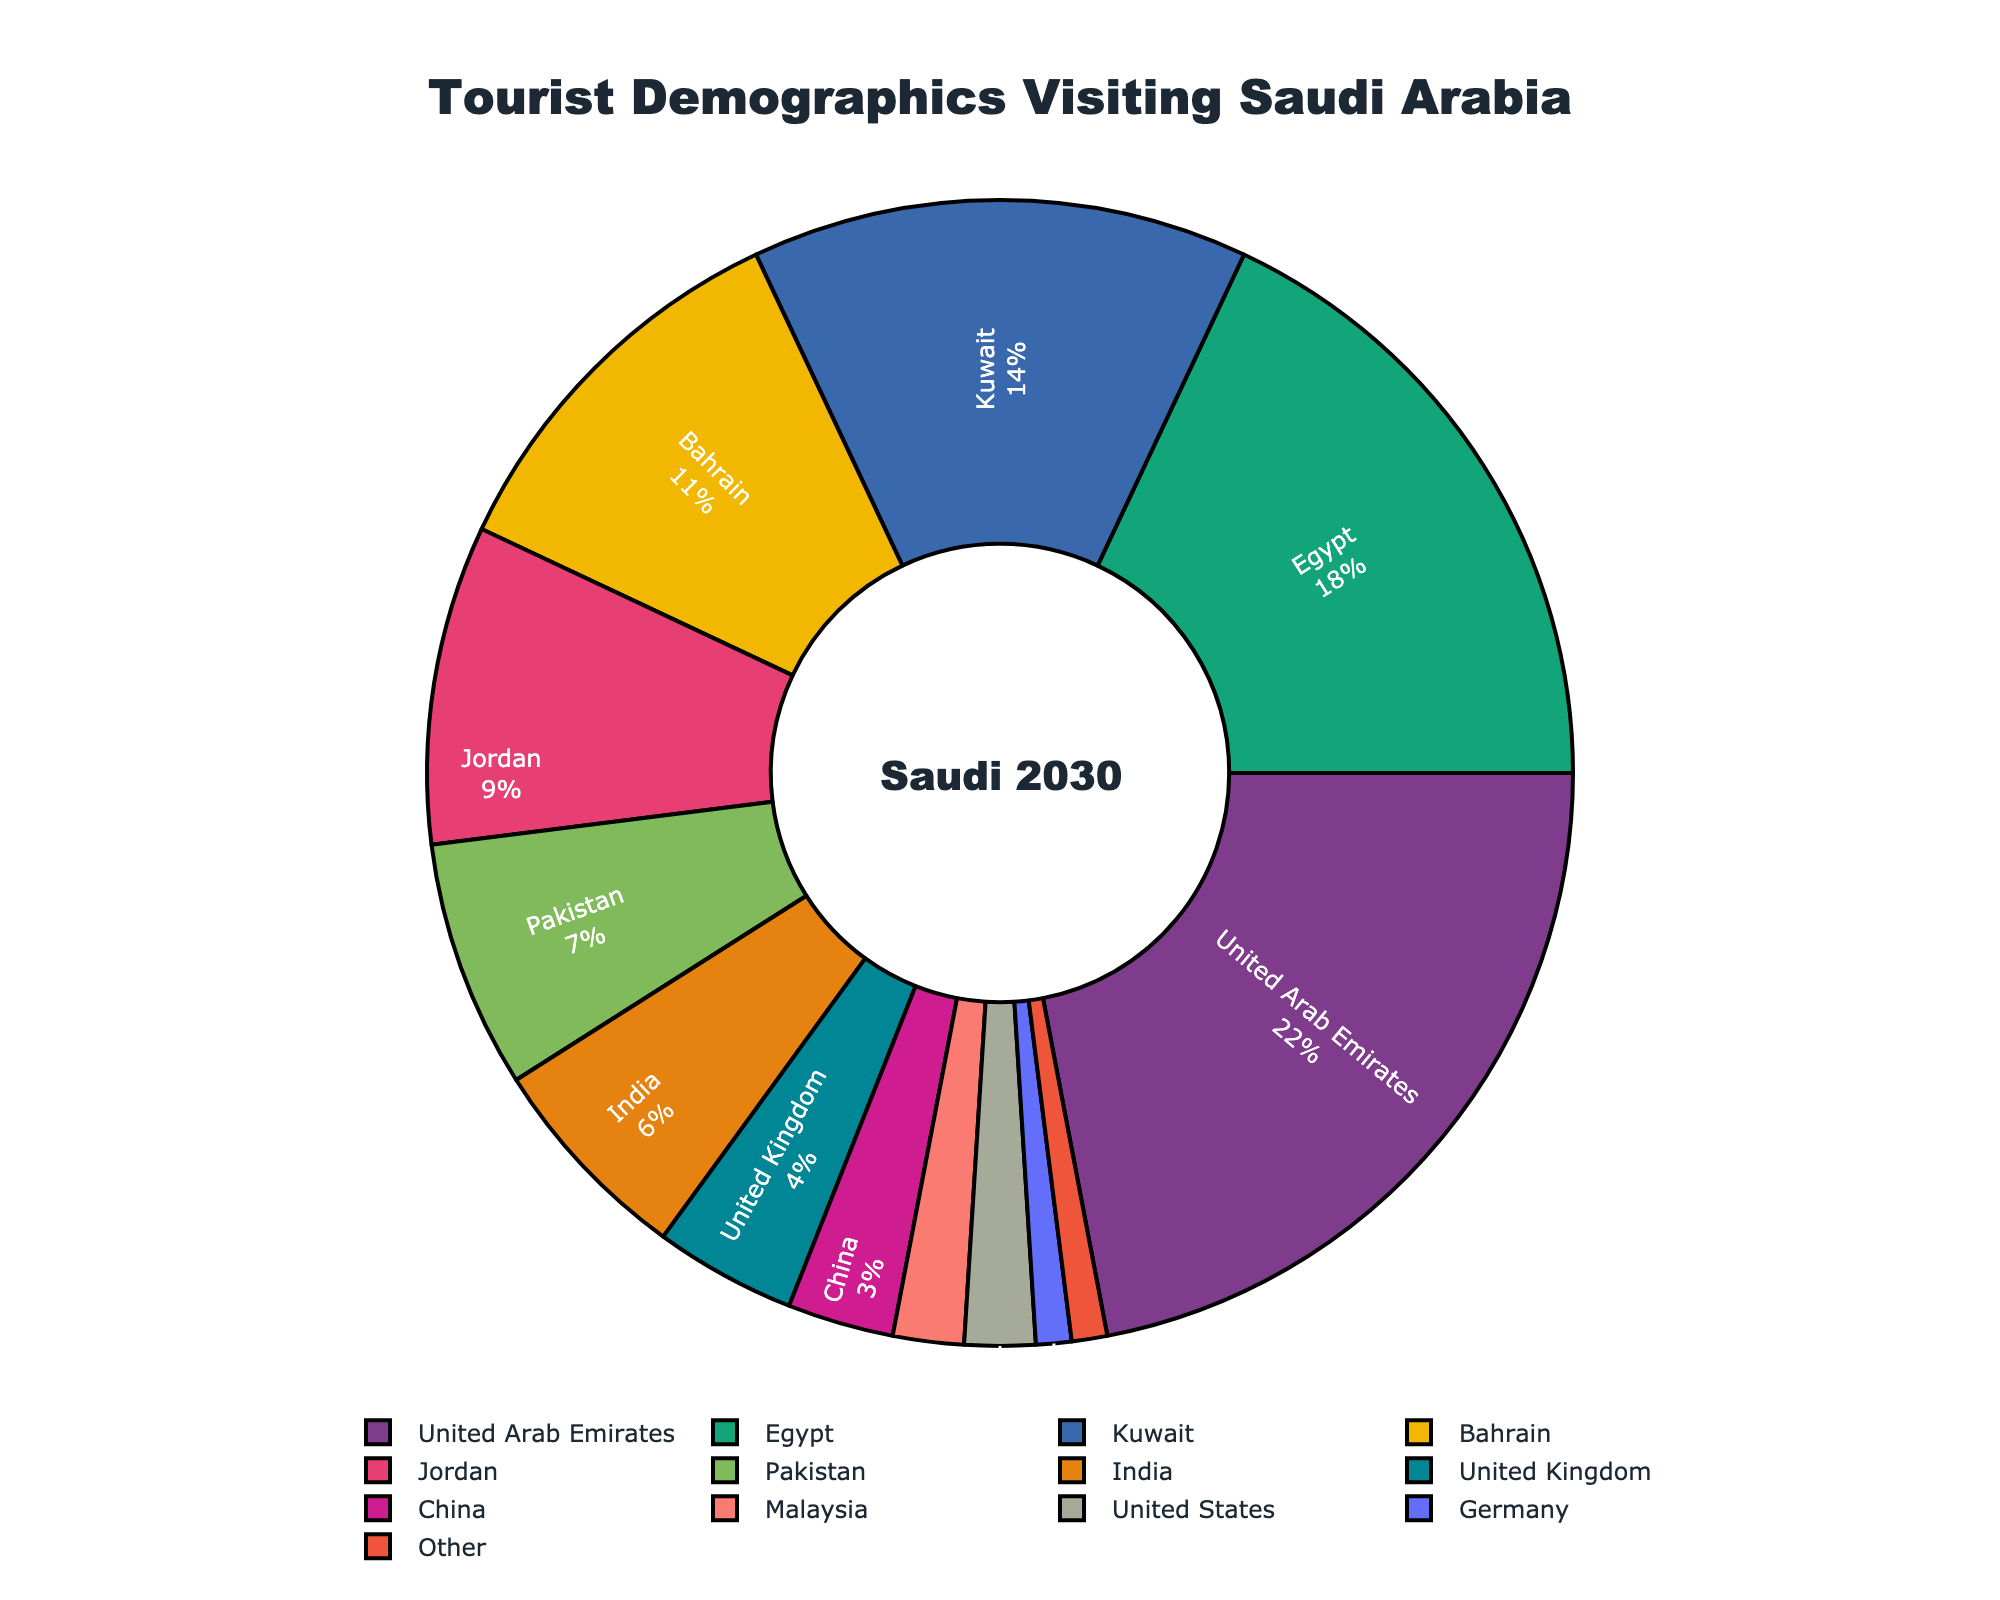Which country has the largest percentage of tourists visiting Saudi Arabia? By looking at the pie chart, the largest segment represents the country with the largest percentage of tourists. The segment for the United Arab Emirates is the largest, making it easy to identify as the country with the highest percentage of tourists.
Answer: United Arab Emirates What is the combined percentage of tourists from Egypt and Kuwait? We can see the percentages for Egypt and Kuwait in the pie chart, which are 18% and 14% respectively. Adding these two percentages together gives us the combined percentage: 18% + 14% = 32%.
Answer: 32% Is the percentage of tourists from Pakistan greater or less than that from Jordan? By observing the pie chart, we see that Pakistan has 7% and Jordan has 9%. Since 7% is less than 9%, we can conclude that the percentage of tourists from Pakistan is less than that of Jordan.
Answer: Less What is the difference in tourist percentages between Bahrain and India? From the pie chart, we see that Bahrain has 11% and India has 6%. To find the difference, we subtract India's percentage from Bahrain's percentage: 11% - 6% = 5%.
Answer: 5% Which three countries together form the smallest proportion of the tourists? The smallest percentages in the pie chart are for Germany (1%), Other (1%), and Malaysia (2%). Adding these percentages together: 1% + 1% + 2% = 4%. These are the three countries with the smallest combined proportion.
Answer: Germany, Other, Malaysia Calculate the percentage difference between tourists from the United Kingdom and China. The pie chart shows that the United Kingdom has 4% and China has 3%. The percentage difference is calculated as (4% - 3%) = 1%.
Answer: 1% What is the average percentage of tourists from all listed countries except "Other"? By adding up the percentages of all listed countries except "Other" (which is 1%), the total is 99%. Dividing this by the 12 countries listed (excluding "Other"): (99% / 12) ≈ 8.25%.
Answer: 8.25% Identify the country represented by the red segment in the pie chart and state its percentage. Visually, the pie chart uses distinguishing colors for each country. The red segment represents Bahrain, which has an 11% share.
Answer: Bahrain, 11% How many countries contribute a total of at least 50% of tourists? Sorting the countries by their percentage contributions: United Arab Emirates (22%), Egypt (18%), and Kuwait (14%) collectively give 22% + 18% + 14% = 54%, which is more than 50%. So, 3 countries contribute at least 50% of the tourists.
Answer: 3 